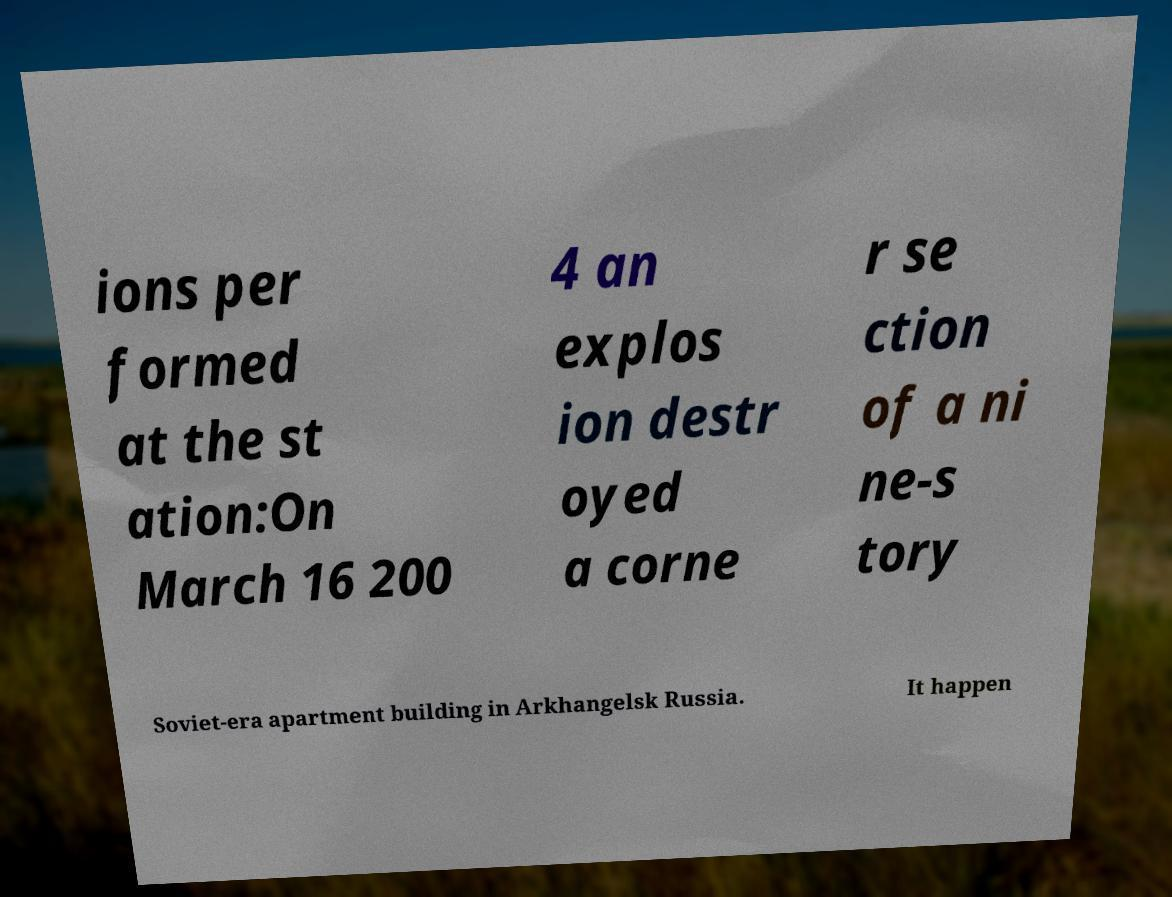I need the written content from this picture converted into text. Can you do that? ions per formed at the st ation:On March 16 200 4 an explos ion destr oyed a corne r se ction of a ni ne-s tory Soviet-era apartment building in Arkhangelsk Russia. It happen 